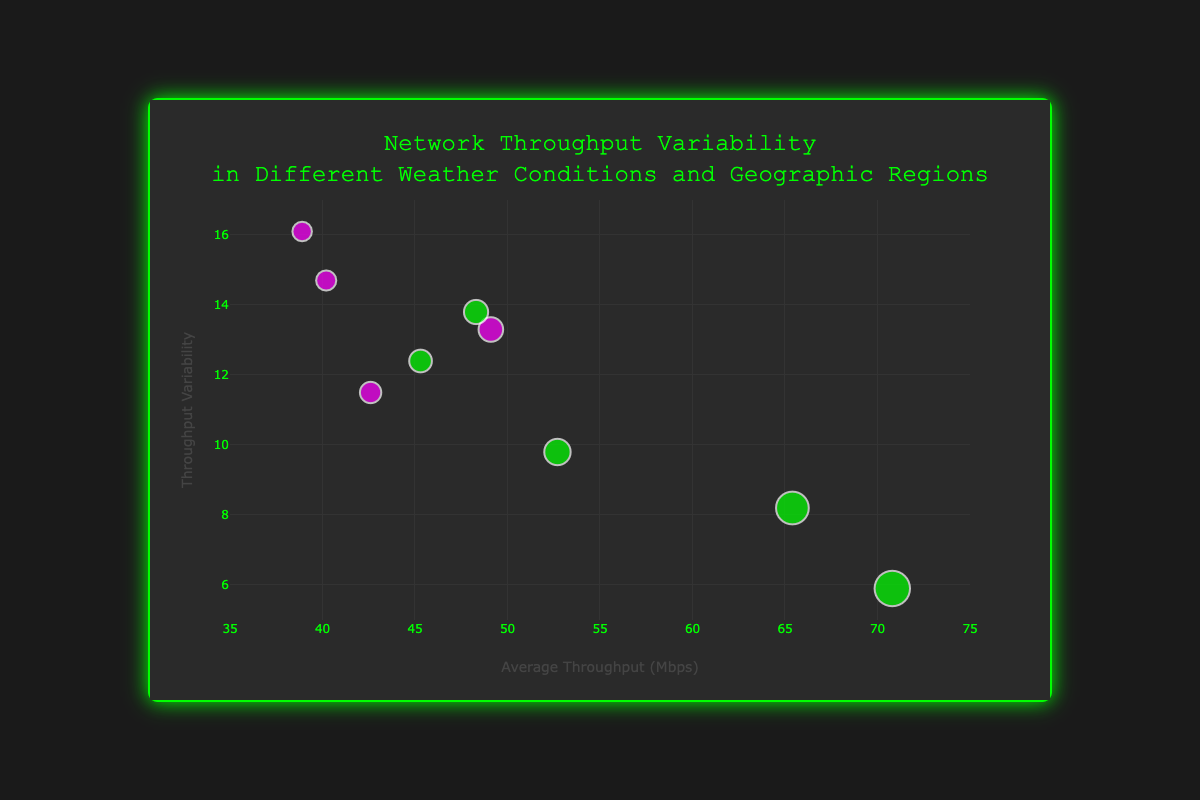What is the title of the bubble chart? The title is located at the top of the chart, written in a larger font size. It reads: "Network Throughput Variability in Different Weather Conditions and Geographic Regions".
Answer: Network Throughput Variability in Different Weather Conditions and Geographic Regions Which axis represents the average throughput in Mbps? The x-axis represents the average throughput in Mbps. This is indicated by the title "Average Throughput (Mbps)" on the x-axis.
Answer: x-axis What color are the data points representing the TCP network protocol? The data points representing the TCP network protocol are colored green. This can be seen by identifying the labels and associated colors in the chart.
Answer: Green How many data points are shown in the Bubble Chart? By counting each marker (bubble) in the chart, we can observe that there are 9 data points, each representing a different location.
Answer: 9 Which location has the highest average throughput and what is its value? The location with the highest average throughput is Phoenix, AZ, with a value of 70.8 Mbps. This can be identified by looking at the x-axis and the hover text when the marker is highlighted.
Answer: Phoenix, AZ with 70.8 Mbps What is the average throughput variability for the location with the highest average throughput? The average throughput variability for Phoenix, AZ, which has the highest average throughput, is 5.9. This can be observed from the corresponding y-axis value for that data point.
Answer: 5.9 Which location and weather condition correspond to the data point with the lowest throughput variability? By examining the y-axis and the hover text, we can identify that Phoenix, AZ with Sunny weather has the lowest throughput variability of 5.9.
Answer: Phoenix, AZ with Sunny weather What is the difference in average throughput between the locations with the highest and lowest throughput? The location with the highest average throughput is Phoenix, AZ (70.8 Mbps), and the one with the lowest is New York, NY (38.9 Mbps). The difference is calculated as 70.8 - 38.9 = 31.9 Mbps.
Answer: 31.9 Mbps Which weather condition appears most frequently in the dataset? By checking the hover text for each data point, we see that the Rainy weather condition appears twice (Houston, TX and Seattle, WA). No other weather condition appears more than once.
Answer: Rainy How does the throughput variability compare between Sunny and Snowy weather conditions? Comparing the markers' y-axis values, the throughputs under Sunny weather conditions (Phoenix, AZ and Miami, FL) have lower variabilities (5.9 and 8.2) compared to those under Snowy conditions (New York, NY and Denver, CO) with higher variabilities (16.1 and 14.7). This indicates that Sunny conditions are associated with lower throughput variability.
Answer: Sunny has lower variability than Snowy 